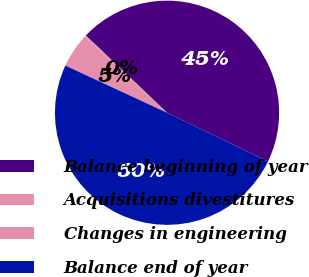Convert chart to OTSL. <chart><loc_0><loc_0><loc_500><loc_500><pie_chart><fcel>Balance beginning of year<fcel>Acquisitions divestitures<fcel>Changes in engineering<fcel>Balance end of year<nl><fcel>45.05%<fcel>0.24%<fcel>4.95%<fcel>49.76%<nl></chart> 